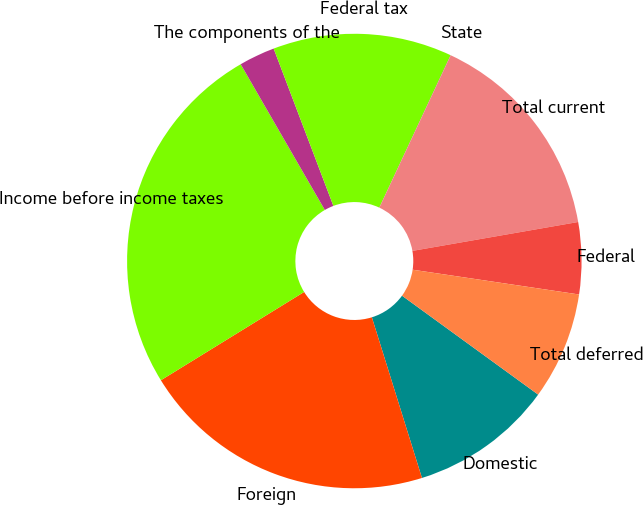Convert chart. <chart><loc_0><loc_0><loc_500><loc_500><pie_chart><fcel>Domestic<fcel>Foreign<fcel>Income before income taxes<fcel>The components of the<fcel>Federal tax<fcel>State<fcel>Total current<fcel>Federal<fcel>Total deferred<nl><fcel>10.19%<fcel>21.02%<fcel>25.46%<fcel>2.56%<fcel>12.74%<fcel>0.01%<fcel>15.28%<fcel>5.1%<fcel>7.65%<nl></chart> 